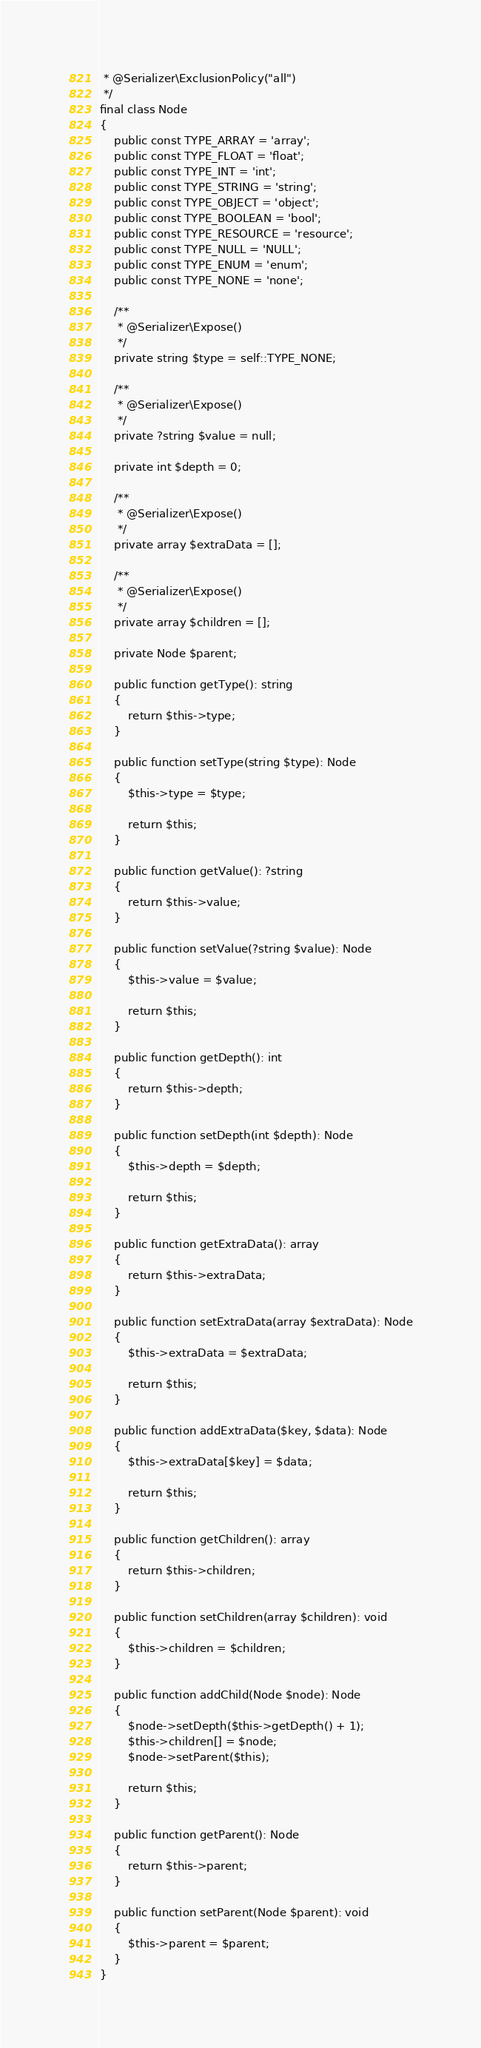Convert code to text. <code><loc_0><loc_0><loc_500><loc_500><_PHP_> * @Serializer\ExclusionPolicy("all")
 */
final class Node
{
    public const TYPE_ARRAY = 'array';
    public const TYPE_FLOAT = 'float';
    public const TYPE_INT = 'int';
    public const TYPE_STRING = 'string';
    public const TYPE_OBJECT = 'object';
    public const TYPE_BOOLEAN = 'bool';
    public const TYPE_RESOURCE = 'resource';
    public const TYPE_NULL = 'NULL';
    public const TYPE_ENUM = 'enum';
    public const TYPE_NONE = 'none';

    /**
     * @Serializer\Expose()
     */
    private string $type = self::TYPE_NONE;

    /**
     * @Serializer\Expose()
     */
    private ?string $value = null;

    private int $depth = 0;

    /**
     * @Serializer\Expose()
     */
    private array $extraData = [];

    /**
     * @Serializer\Expose()
     */
    private array $children = [];

    private Node $parent;

    public function getType(): string
    {
        return $this->type;
    }

    public function setType(string $type): Node
    {
        $this->type = $type;

        return $this;
    }

    public function getValue(): ?string
    {
        return $this->value;
    }

    public function setValue(?string $value): Node
    {
        $this->value = $value;

        return $this;
    }

    public function getDepth(): int
    {
        return $this->depth;
    }

    public function setDepth(int $depth): Node
    {
        $this->depth = $depth;

        return $this;
    }

    public function getExtraData(): array
    {
        return $this->extraData;
    }

    public function setExtraData(array $extraData): Node
    {
        $this->extraData = $extraData;

        return $this;
    }

    public function addExtraData($key, $data): Node
    {
        $this->extraData[$key] = $data;

        return $this;
    }

    public function getChildren(): array
    {
        return $this->children;
    }

    public function setChildren(array $children): void
    {
        $this->children = $children;
    }

    public function addChild(Node $node): Node
    {
        $node->setDepth($this->getDepth() + 1);
        $this->children[] = $node;
        $node->setParent($this);

        return $this;
    }

    public function getParent(): Node
    {
        return $this->parent;
    }

    public function setParent(Node $parent): void
    {
        $this->parent = $parent;
    }
}
</code> 